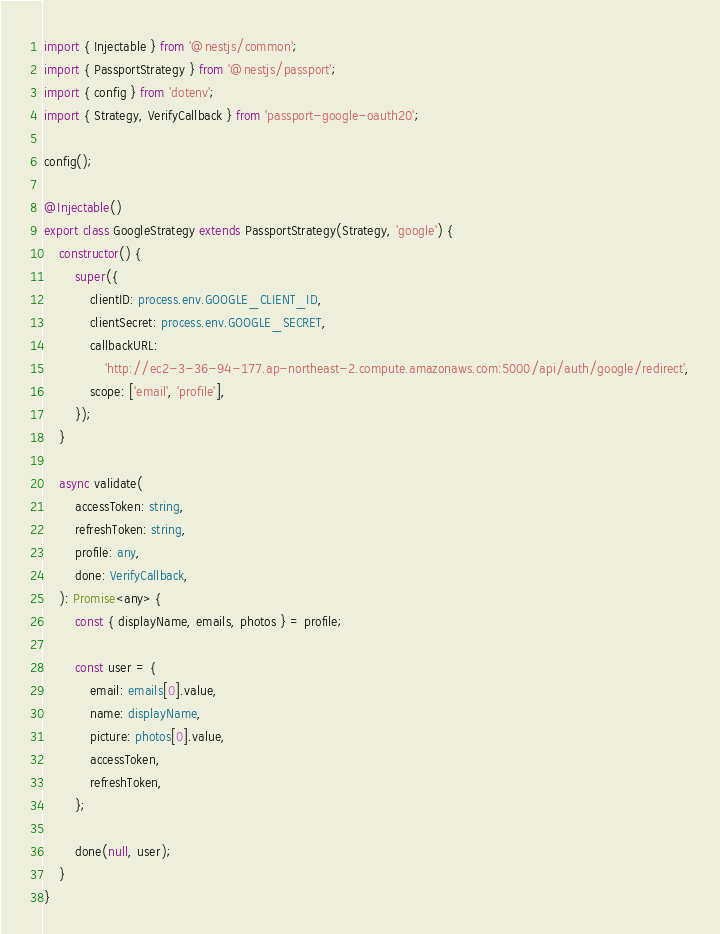Convert code to text. <code><loc_0><loc_0><loc_500><loc_500><_TypeScript_>import { Injectable } from '@nestjs/common';
import { PassportStrategy } from '@nestjs/passport';
import { config } from 'dotenv';
import { Strategy, VerifyCallback } from 'passport-google-oauth20';

config();

@Injectable()
export class GoogleStrategy extends PassportStrategy(Strategy, 'google') {
    constructor() {
        super({
            clientID: process.env.GOOGLE_CLIENT_ID,
            clientSecret: process.env.GOOGLE_SECRET,
            callbackURL:
                'http://ec2-3-36-94-177.ap-northeast-2.compute.amazonaws.com:5000/api/auth/google/redirect',
            scope: ['email', 'profile'],
        });
    }

    async validate(
        accessToken: string,
        refreshToken: string,
        profile: any,
        done: VerifyCallback,
    ): Promise<any> {
        const { displayName, emails, photos } = profile;

        const user = {
            email: emails[0].value,
            name: displayName,
            picture: photos[0].value,
            accessToken,
            refreshToken,
        };

        done(null, user);
    }
}
</code> 